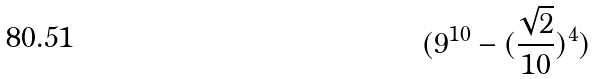<formula> <loc_0><loc_0><loc_500><loc_500>( 9 ^ { 1 0 } - ( \frac { \sqrt { 2 } } { 1 0 } ) ^ { 4 } )</formula> 